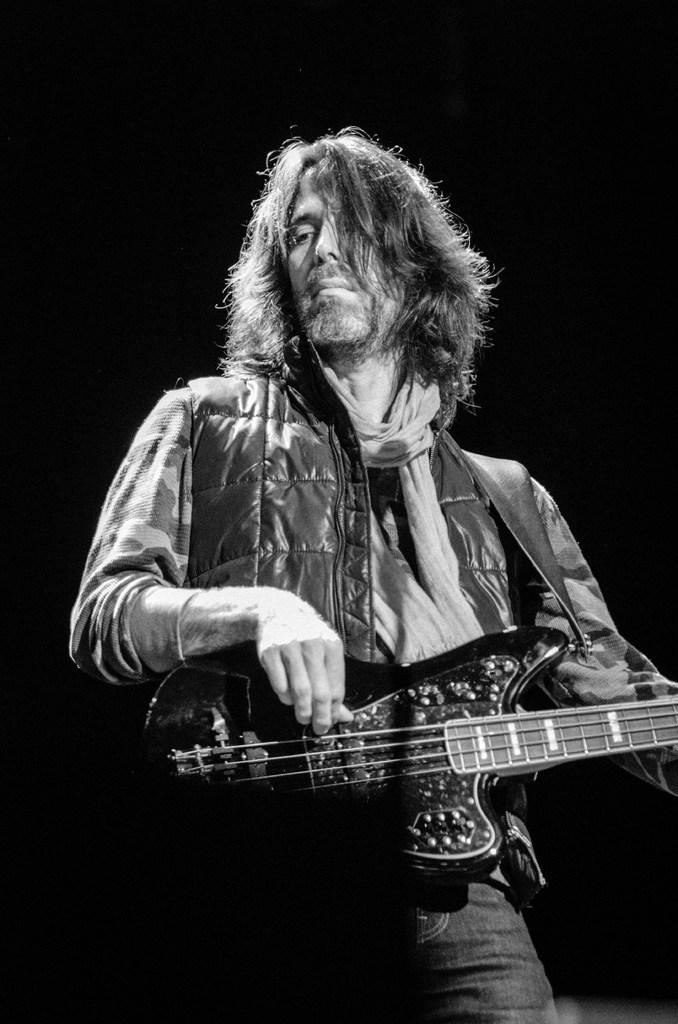What is the color scheme of the image? The image is black and white. Who is present in the image? There is a man in the image. What is the man holding in the image? The man is holding a guitar. What can be seen behind the man in the image? The background of the man is black. How many kittens are sitting on the man's stomach in the image? There are no kittens present in the image, and the man's stomach is not visible. 